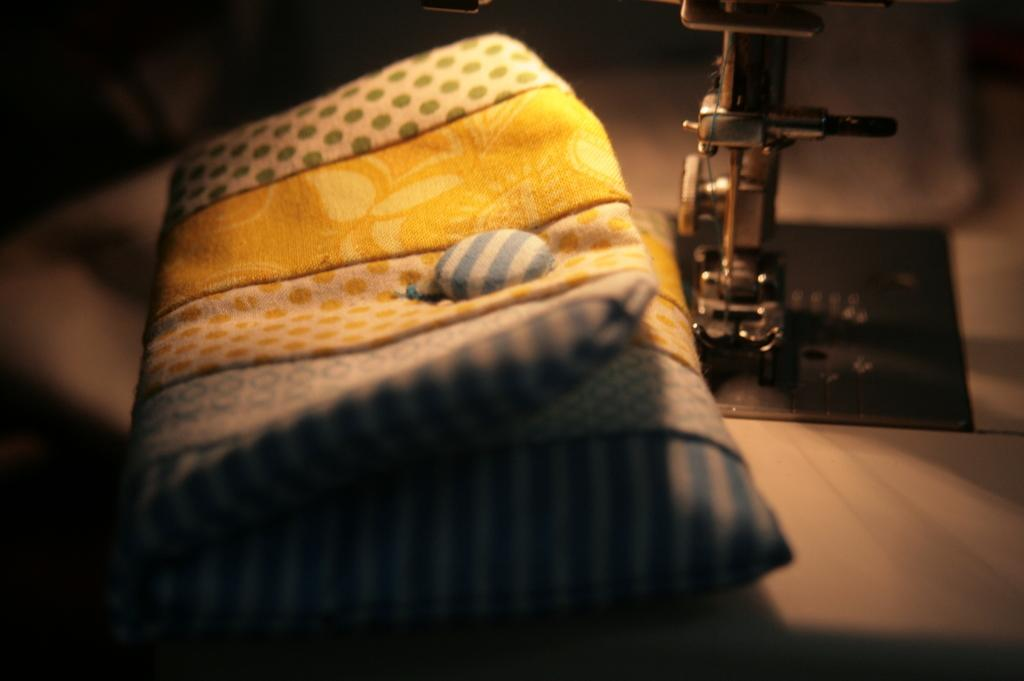What is the main object in the image? There is a pillow in the image. Can you describe the object on the black color mat? Unfortunately, the facts provided do not mention an object on a black color mat. What type of bubble can be seen on the pillow in the image? There is no bubble present on the pillow in the image. How many cherries are on the pillow in the image? There are no cherries present on the pillow in the image. 